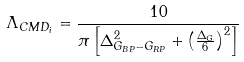<formula> <loc_0><loc_0><loc_500><loc_500>\Lambda _ { C M D _ { i } } = \frac { 1 0 } { \pi \left [ \Delta _ { G _ { B P } - G _ { R P } } ^ { 2 } + \left ( \frac { \Delta _ { G } } { 6 } \right ) ^ { 2 } \right ] }</formula> 